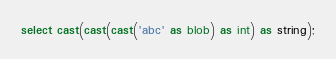<code> <loc_0><loc_0><loc_500><loc_500><_SQL_>select cast(cast(cast('abc' as blob) as int) as string);
</code> 